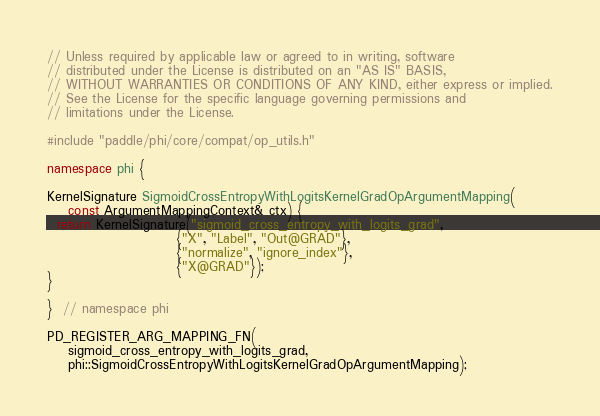<code> <loc_0><loc_0><loc_500><loc_500><_C++_>// Unless required by applicable law or agreed to in writing, software
// distributed under the License is distributed on an "AS IS" BASIS,
// WITHOUT WARRANTIES OR CONDITIONS OF ANY KIND, either express or implied.
// See the License for the specific language governing permissions and
// limitations under the License.

#include "paddle/phi/core/compat/op_utils.h"

namespace phi {

KernelSignature SigmoidCrossEntropyWithLogitsKernelGradOpArgumentMapping(
    const ArgumentMappingContext& ctx) {
  return KernelSignature("sigmoid_cross_entropy_with_logits_grad",
                         {"X", "Label", "Out@GRAD"},
                         {"normalize", "ignore_index"},
                         {"X@GRAD"});
}

}  // namespace phi

PD_REGISTER_ARG_MAPPING_FN(
    sigmoid_cross_entropy_with_logits_grad,
    phi::SigmoidCrossEntropyWithLogitsKernelGradOpArgumentMapping);
</code> 